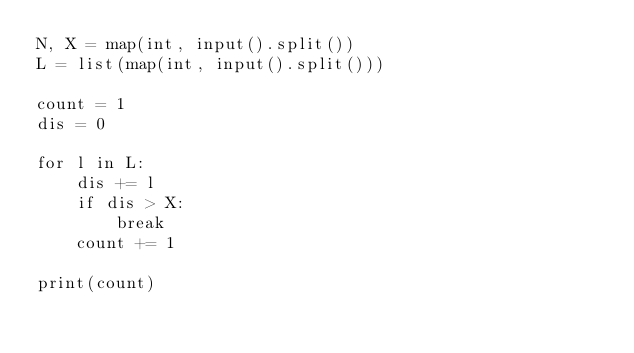Convert code to text. <code><loc_0><loc_0><loc_500><loc_500><_Python_>N, X = map(int, input().split())
L = list(map(int, input().split()))

count = 1
dis = 0

for l in L:
    dis += l
    if dis > X:
        break
    count += 1

print(count)</code> 